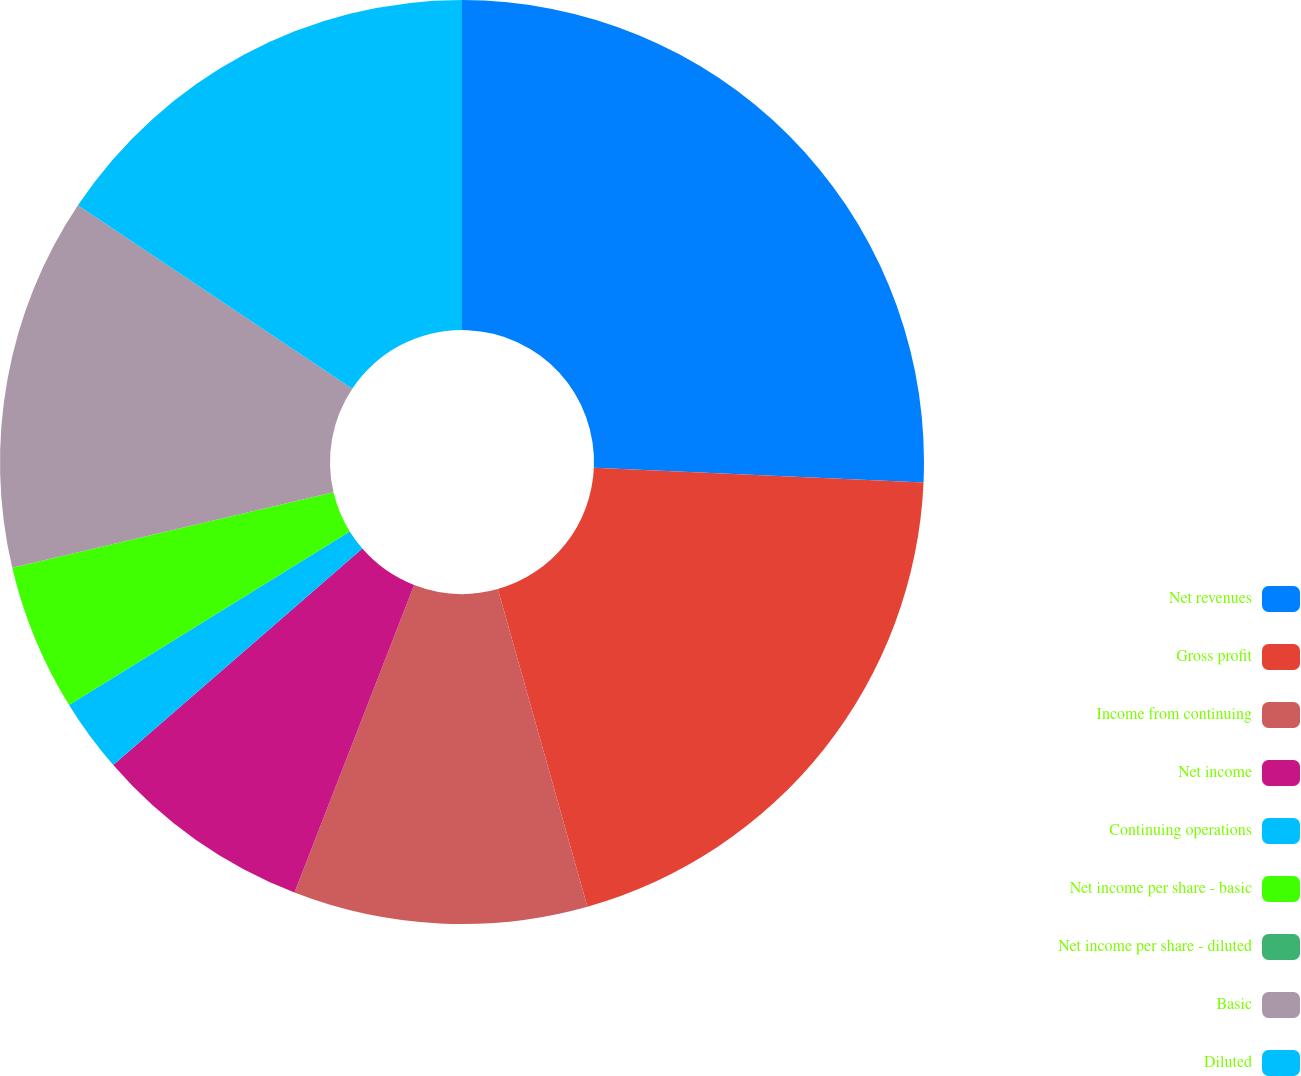Convert chart. <chart><loc_0><loc_0><loc_500><loc_500><pie_chart><fcel>Net revenues<fcel>Gross profit<fcel>Income from continuing<fcel>Net income<fcel>Continuing operations<fcel>Net income per share - basic<fcel>Net income per share - diluted<fcel>Basic<fcel>Diluted<nl><fcel>25.7%<fcel>19.92%<fcel>10.28%<fcel>7.71%<fcel>2.57%<fcel>5.14%<fcel>0.0%<fcel>13.05%<fcel>15.62%<nl></chart> 